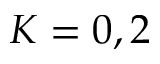<formula> <loc_0><loc_0><loc_500><loc_500>K = 0 , 2</formula> 